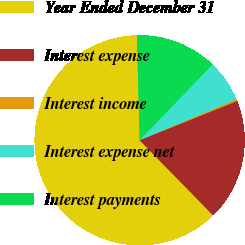Convert chart to OTSL. <chart><loc_0><loc_0><loc_500><loc_500><pie_chart><fcel>Year Ended December 31<fcel>Interest expense<fcel>Interest income<fcel>Interest expense net<fcel>Interest payments<nl><fcel>61.91%<fcel>18.77%<fcel>0.28%<fcel>6.44%<fcel>12.6%<nl></chart> 